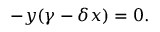<formula> <loc_0><loc_0><loc_500><loc_500>- y ( \gamma - \delta x ) = 0 .</formula> 